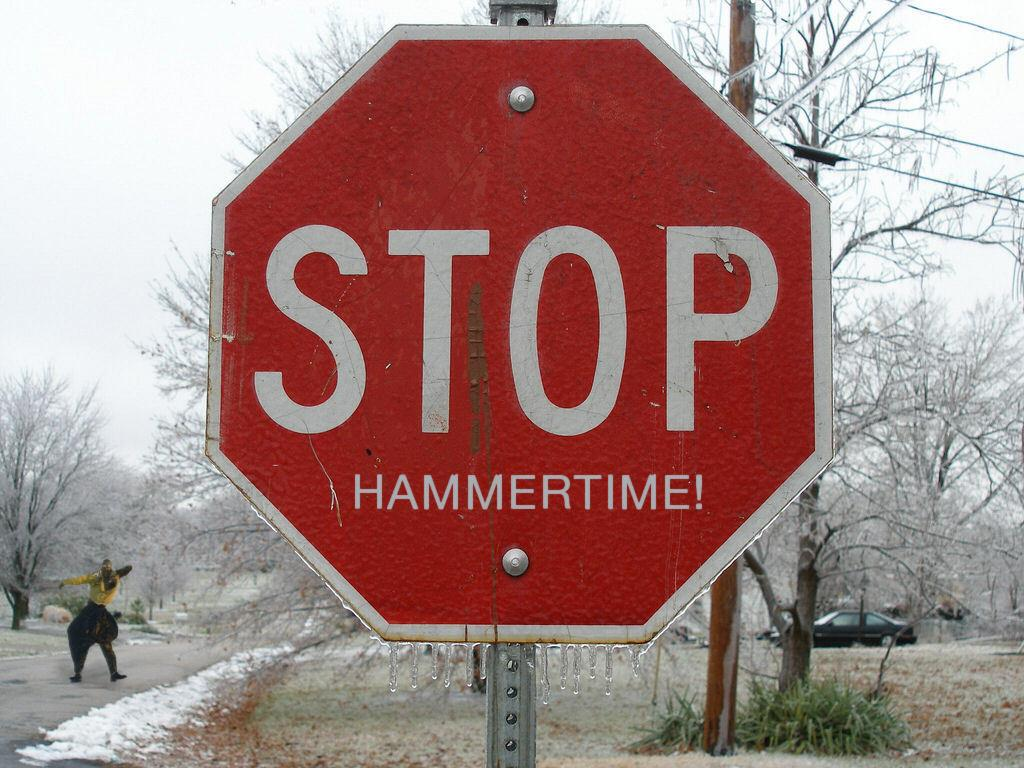<image>
Write a terse but informative summary of the picture. a stop sign that has many things around it 